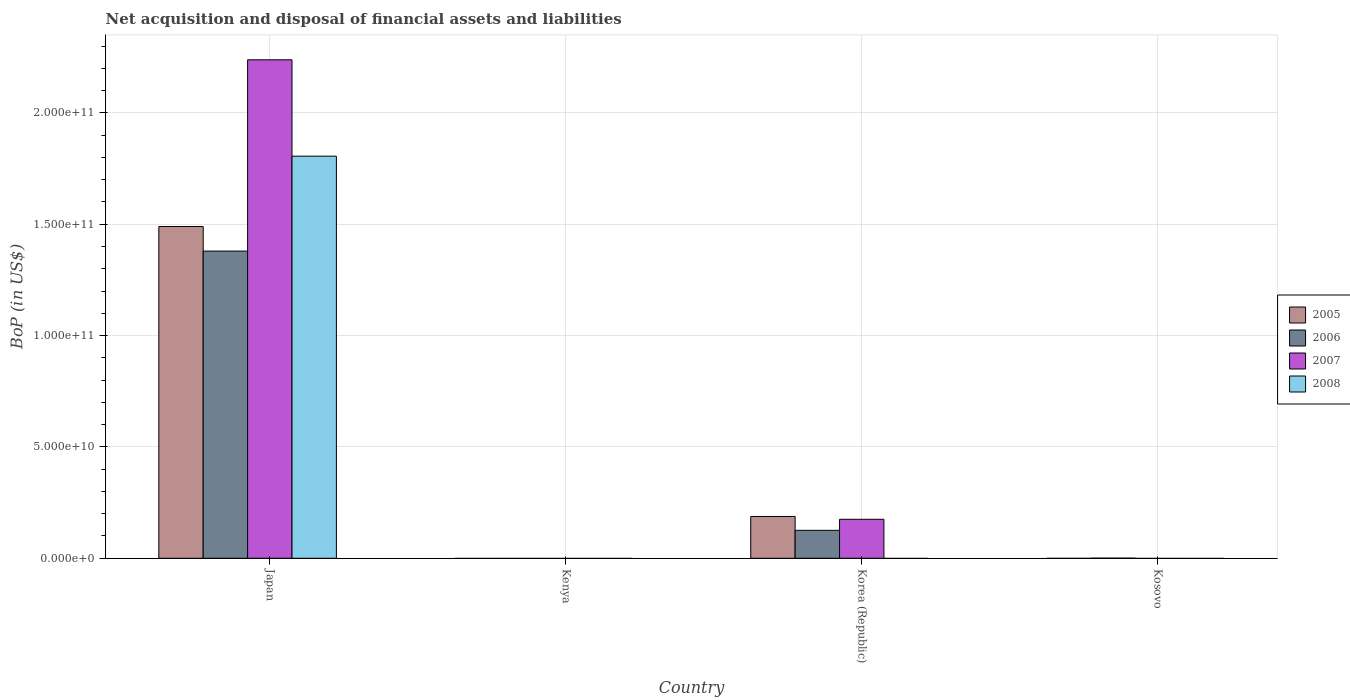Are the number of bars per tick equal to the number of legend labels?
Ensure brevity in your answer.  No. Are the number of bars on each tick of the X-axis equal?
Ensure brevity in your answer.  No. What is the label of the 2nd group of bars from the left?
Ensure brevity in your answer.  Kenya. In how many cases, is the number of bars for a given country not equal to the number of legend labels?
Offer a very short reply. 3. What is the Balance of Payments in 2007 in Korea (Republic)?
Provide a short and direct response. 1.75e+1. Across all countries, what is the maximum Balance of Payments in 2005?
Your answer should be very brief. 1.49e+11. Across all countries, what is the minimum Balance of Payments in 2007?
Provide a succinct answer. 0. In which country was the Balance of Payments in 2007 maximum?
Provide a succinct answer. Japan. What is the total Balance of Payments in 2007 in the graph?
Your answer should be very brief. 2.41e+11. What is the difference between the Balance of Payments in 2006 in Japan and that in Korea (Republic)?
Your response must be concise. 1.25e+11. What is the difference between the Balance of Payments in 2006 in Japan and the Balance of Payments in 2008 in Korea (Republic)?
Your answer should be very brief. 1.38e+11. What is the average Balance of Payments in 2005 per country?
Give a very brief answer. 4.19e+1. What is the difference between the Balance of Payments of/in 2006 and Balance of Payments of/in 2007 in Korea (Republic)?
Your answer should be compact. -4.95e+09. What is the ratio of the Balance of Payments in 2007 in Japan to that in Korea (Republic)?
Your answer should be compact. 12.79. What is the difference between the highest and the second highest Balance of Payments in 2006?
Make the answer very short. 1.38e+11. What is the difference between the highest and the lowest Balance of Payments in 2005?
Make the answer very short. 1.49e+11. In how many countries, is the Balance of Payments in 2008 greater than the average Balance of Payments in 2008 taken over all countries?
Offer a terse response. 1. Is it the case that in every country, the sum of the Balance of Payments in 2007 and Balance of Payments in 2005 is greater than the sum of Balance of Payments in 2006 and Balance of Payments in 2008?
Your answer should be compact. No. Is it the case that in every country, the sum of the Balance of Payments in 2005 and Balance of Payments in 2006 is greater than the Balance of Payments in 2008?
Give a very brief answer. No. How many bars are there?
Give a very brief answer. 8. What is the difference between two consecutive major ticks on the Y-axis?
Keep it short and to the point. 5.00e+1. Are the values on the major ticks of Y-axis written in scientific E-notation?
Offer a terse response. Yes. Does the graph contain any zero values?
Ensure brevity in your answer.  Yes. How many legend labels are there?
Ensure brevity in your answer.  4. How are the legend labels stacked?
Offer a terse response. Vertical. What is the title of the graph?
Provide a short and direct response. Net acquisition and disposal of financial assets and liabilities. Does "2001" appear as one of the legend labels in the graph?
Offer a terse response. No. What is the label or title of the X-axis?
Give a very brief answer. Country. What is the label or title of the Y-axis?
Your answer should be compact. BoP (in US$). What is the BoP (in US$) in 2005 in Japan?
Make the answer very short. 1.49e+11. What is the BoP (in US$) in 2006 in Japan?
Provide a short and direct response. 1.38e+11. What is the BoP (in US$) in 2007 in Japan?
Your answer should be very brief. 2.24e+11. What is the BoP (in US$) of 2008 in Japan?
Your response must be concise. 1.81e+11. What is the BoP (in US$) in 2005 in Kenya?
Keep it short and to the point. 0. What is the BoP (in US$) in 2006 in Kenya?
Give a very brief answer. 0. What is the BoP (in US$) of 2008 in Kenya?
Your response must be concise. 0. What is the BoP (in US$) of 2005 in Korea (Republic)?
Ensure brevity in your answer.  1.88e+1. What is the BoP (in US$) in 2006 in Korea (Republic)?
Give a very brief answer. 1.25e+1. What is the BoP (in US$) of 2007 in Korea (Republic)?
Keep it short and to the point. 1.75e+1. What is the BoP (in US$) of 2005 in Kosovo?
Provide a short and direct response. 0. What is the BoP (in US$) of 2006 in Kosovo?
Keep it short and to the point. 4.48e+07. What is the BoP (in US$) of 2007 in Kosovo?
Keep it short and to the point. 0. What is the BoP (in US$) of 2008 in Kosovo?
Your response must be concise. 0. Across all countries, what is the maximum BoP (in US$) in 2005?
Your answer should be very brief. 1.49e+11. Across all countries, what is the maximum BoP (in US$) of 2006?
Your response must be concise. 1.38e+11. Across all countries, what is the maximum BoP (in US$) in 2007?
Your response must be concise. 2.24e+11. Across all countries, what is the maximum BoP (in US$) of 2008?
Provide a short and direct response. 1.81e+11. Across all countries, what is the minimum BoP (in US$) of 2005?
Provide a short and direct response. 0. Across all countries, what is the minimum BoP (in US$) of 2007?
Your answer should be very brief. 0. What is the total BoP (in US$) of 2005 in the graph?
Your response must be concise. 1.68e+11. What is the total BoP (in US$) in 2006 in the graph?
Provide a short and direct response. 1.51e+11. What is the total BoP (in US$) of 2007 in the graph?
Your answer should be compact. 2.41e+11. What is the total BoP (in US$) in 2008 in the graph?
Offer a terse response. 1.81e+11. What is the difference between the BoP (in US$) in 2005 in Japan and that in Korea (Republic)?
Your response must be concise. 1.30e+11. What is the difference between the BoP (in US$) of 2006 in Japan and that in Korea (Republic)?
Offer a terse response. 1.25e+11. What is the difference between the BoP (in US$) in 2007 in Japan and that in Korea (Republic)?
Provide a short and direct response. 2.06e+11. What is the difference between the BoP (in US$) of 2006 in Japan and that in Kosovo?
Provide a short and direct response. 1.38e+11. What is the difference between the BoP (in US$) of 2006 in Korea (Republic) and that in Kosovo?
Provide a short and direct response. 1.25e+1. What is the difference between the BoP (in US$) in 2005 in Japan and the BoP (in US$) in 2006 in Korea (Republic)?
Your answer should be compact. 1.36e+11. What is the difference between the BoP (in US$) of 2005 in Japan and the BoP (in US$) of 2007 in Korea (Republic)?
Offer a terse response. 1.31e+11. What is the difference between the BoP (in US$) in 2006 in Japan and the BoP (in US$) in 2007 in Korea (Republic)?
Offer a very short reply. 1.20e+11. What is the difference between the BoP (in US$) in 2005 in Japan and the BoP (in US$) in 2006 in Kosovo?
Provide a succinct answer. 1.49e+11. What is the difference between the BoP (in US$) in 2005 in Korea (Republic) and the BoP (in US$) in 2006 in Kosovo?
Ensure brevity in your answer.  1.87e+1. What is the average BoP (in US$) in 2005 per country?
Your answer should be very brief. 4.19e+1. What is the average BoP (in US$) of 2006 per country?
Ensure brevity in your answer.  3.76e+1. What is the average BoP (in US$) of 2007 per country?
Give a very brief answer. 6.03e+1. What is the average BoP (in US$) of 2008 per country?
Provide a succinct answer. 4.51e+1. What is the difference between the BoP (in US$) of 2005 and BoP (in US$) of 2006 in Japan?
Give a very brief answer. 1.10e+1. What is the difference between the BoP (in US$) of 2005 and BoP (in US$) of 2007 in Japan?
Your answer should be very brief. -7.49e+1. What is the difference between the BoP (in US$) of 2005 and BoP (in US$) of 2008 in Japan?
Make the answer very short. -3.16e+1. What is the difference between the BoP (in US$) in 2006 and BoP (in US$) in 2007 in Japan?
Your answer should be compact. -8.59e+1. What is the difference between the BoP (in US$) of 2006 and BoP (in US$) of 2008 in Japan?
Offer a terse response. -4.26e+1. What is the difference between the BoP (in US$) of 2007 and BoP (in US$) of 2008 in Japan?
Offer a very short reply. 4.33e+1. What is the difference between the BoP (in US$) in 2005 and BoP (in US$) in 2006 in Korea (Republic)?
Your answer should be compact. 6.23e+09. What is the difference between the BoP (in US$) in 2005 and BoP (in US$) in 2007 in Korea (Republic)?
Make the answer very short. 1.28e+09. What is the difference between the BoP (in US$) in 2006 and BoP (in US$) in 2007 in Korea (Republic)?
Your answer should be very brief. -4.95e+09. What is the ratio of the BoP (in US$) in 2005 in Japan to that in Korea (Republic)?
Your answer should be compact. 7.94. What is the ratio of the BoP (in US$) of 2006 in Japan to that in Korea (Republic)?
Keep it short and to the point. 10.99. What is the ratio of the BoP (in US$) of 2007 in Japan to that in Korea (Republic)?
Offer a terse response. 12.79. What is the ratio of the BoP (in US$) in 2006 in Japan to that in Kosovo?
Your answer should be very brief. 3078.63. What is the ratio of the BoP (in US$) of 2006 in Korea (Republic) to that in Kosovo?
Provide a succinct answer. 280.03. What is the difference between the highest and the second highest BoP (in US$) of 2006?
Provide a short and direct response. 1.25e+11. What is the difference between the highest and the lowest BoP (in US$) of 2005?
Keep it short and to the point. 1.49e+11. What is the difference between the highest and the lowest BoP (in US$) of 2006?
Give a very brief answer. 1.38e+11. What is the difference between the highest and the lowest BoP (in US$) of 2007?
Provide a short and direct response. 2.24e+11. What is the difference between the highest and the lowest BoP (in US$) of 2008?
Give a very brief answer. 1.81e+11. 